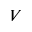<formula> <loc_0><loc_0><loc_500><loc_500>V</formula> 